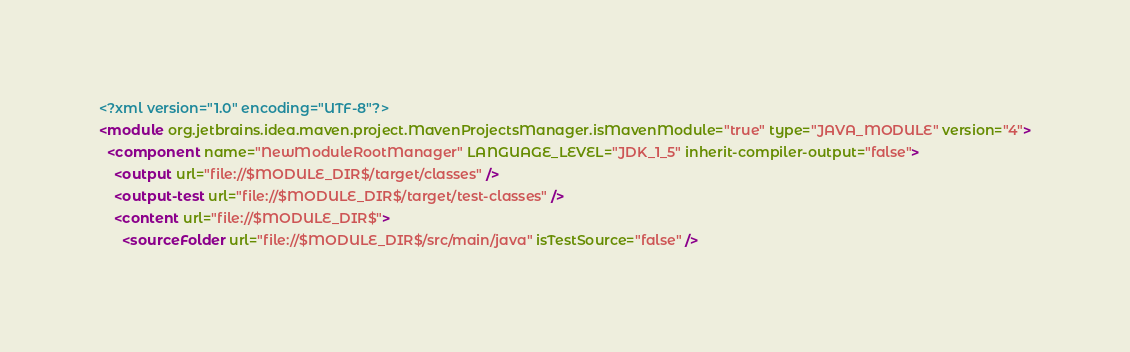<code> <loc_0><loc_0><loc_500><loc_500><_XML_><?xml version="1.0" encoding="UTF-8"?>
<module org.jetbrains.idea.maven.project.MavenProjectsManager.isMavenModule="true" type="JAVA_MODULE" version="4">
  <component name="NewModuleRootManager" LANGUAGE_LEVEL="JDK_1_5" inherit-compiler-output="false">
    <output url="file://$MODULE_DIR$/target/classes" />
    <output-test url="file://$MODULE_DIR$/target/test-classes" />
    <content url="file://$MODULE_DIR$">
      <sourceFolder url="file://$MODULE_DIR$/src/main/java" isTestSource="false" /></code> 